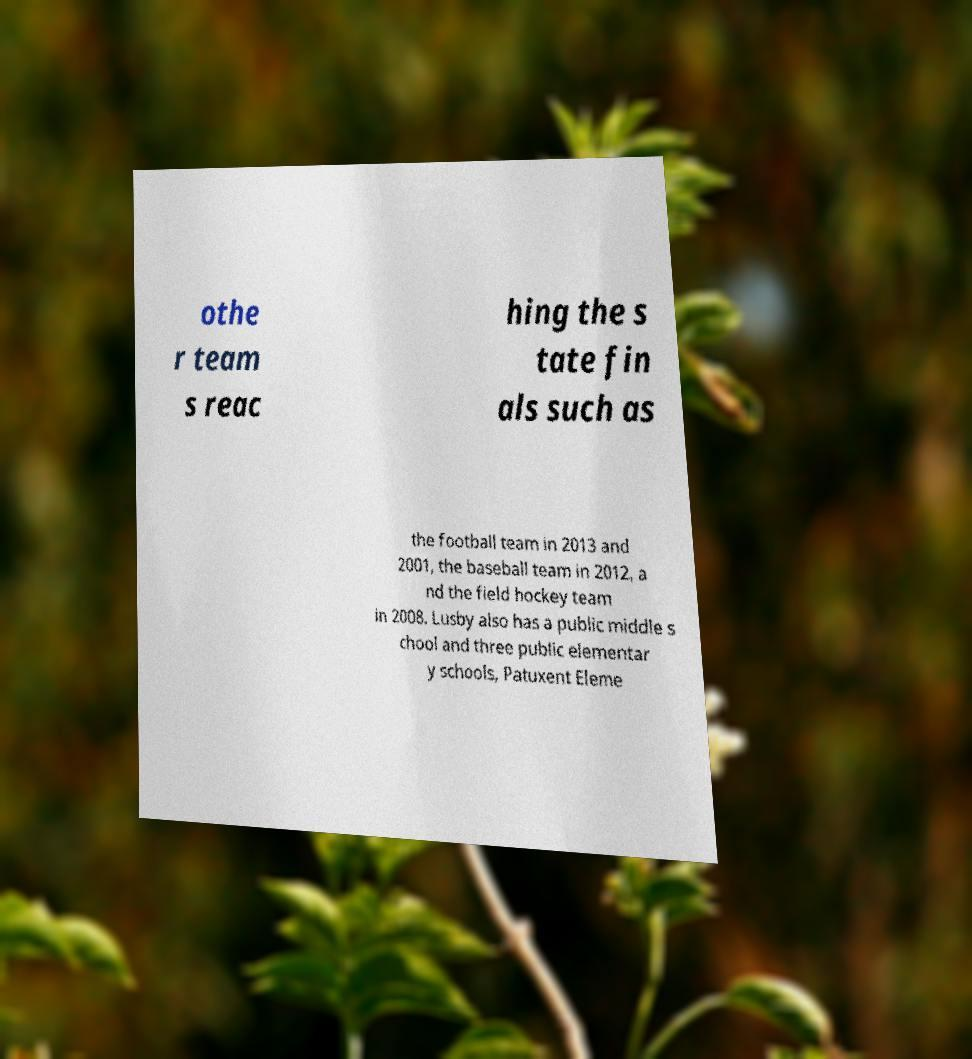I need the written content from this picture converted into text. Can you do that? othe r team s reac hing the s tate fin als such as the football team in 2013 and 2001, the baseball team in 2012, a nd the field hockey team in 2008. Lusby also has a public middle s chool and three public elementar y schools, Patuxent Eleme 